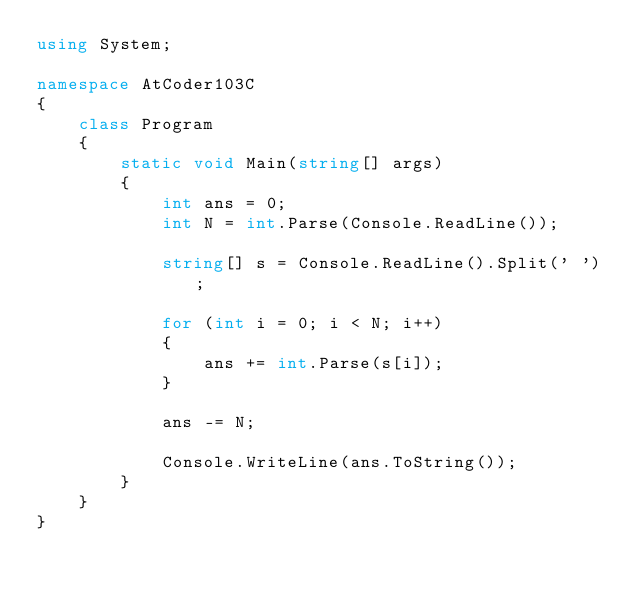<code> <loc_0><loc_0><loc_500><loc_500><_C#_>using System;

namespace AtCoder103C
{
    class Program
    {
        static void Main(string[] args)
        {
            int ans = 0;
            int N = int.Parse(Console.ReadLine());

            string[] s = Console.ReadLine().Split(' ');

            for (int i = 0; i < N; i++)
            {
                ans += int.Parse(s[i]);
            }

            ans -= N;

            Console.WriteLine(ans.ToString());
        }
    }
}
</code> 